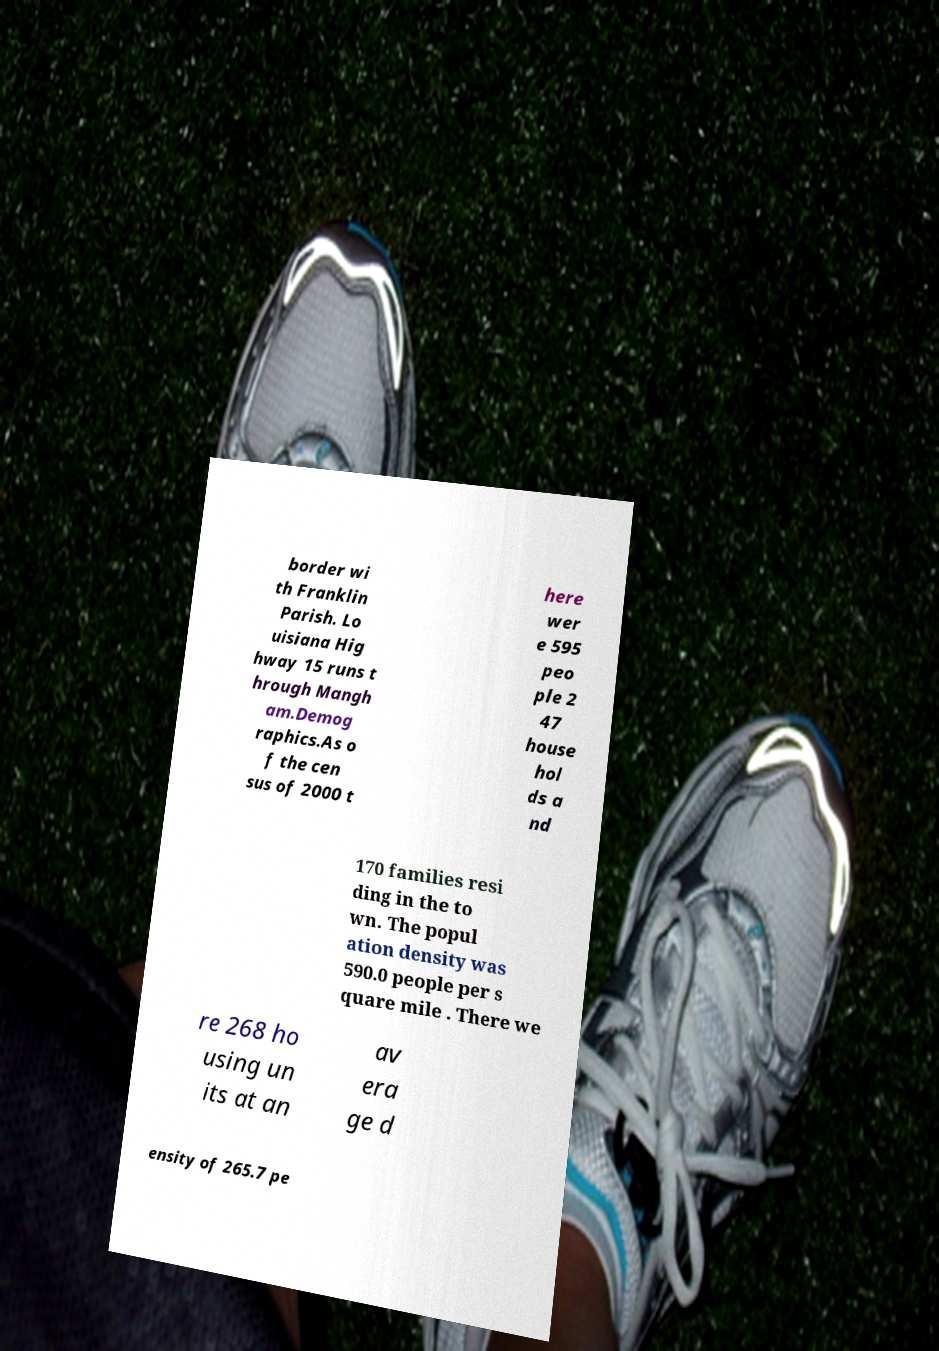Could you assist in decoding the text presented in this image and type it out clearly? border wi th Franklin Parish. Lo uisiana Hig hway 15 runs t hrough Mangh am.Demog raphics.As o f the cen sus of 2000 t here wer e 595 peo ple 2 47 house hol ds a nd 170 families resi ding in the to wn. The popul ation density was 590.0 people per s quare mile . There we re 268 ho using un its at an av era ge d ensity of 265.7 pe 